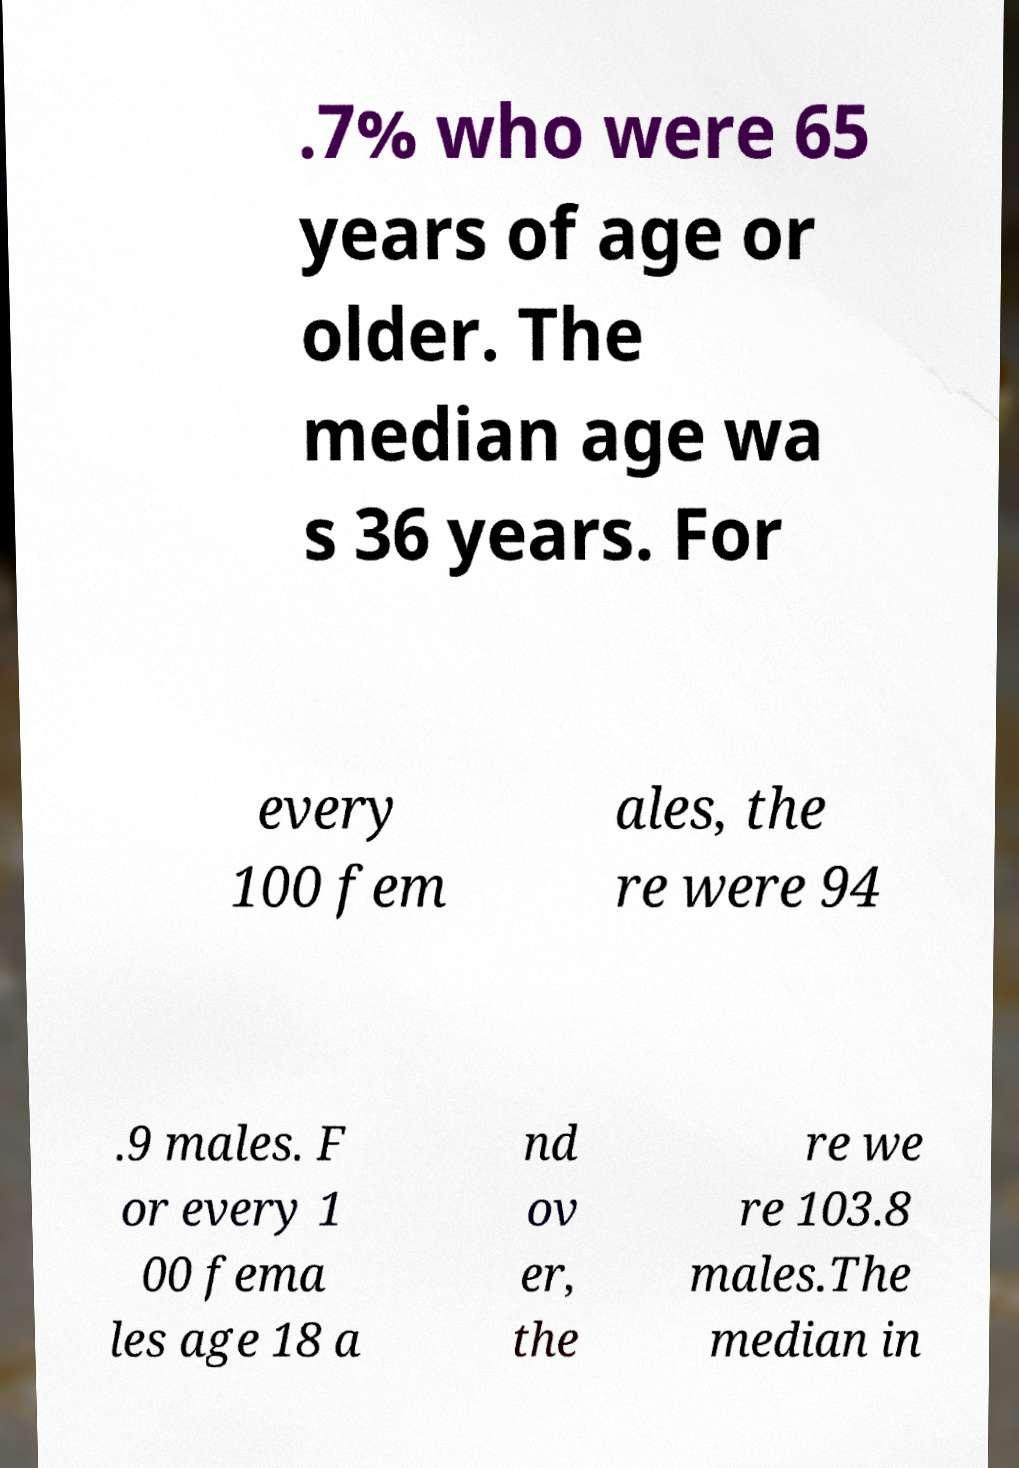Can you read and provide the text displayed in the image?This photo seems to have some interesting text. Can you extract and type it out for me? .7% who were 65 years of age or older. The median age wa s 36 years. For every 100 fem ales, the re were 94 .9 males. F or every 1 00 fema les age 18 a nd ov er, the re we re 103.8 males.The median in 